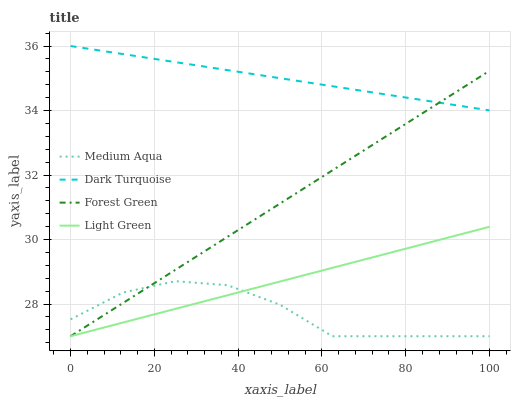Does Medium Aqua have the minimum area under the curve?
Answer yes or no. Yes. Does Dark Turquoise have the maximum area under the curve?
Answer yes or no. Yes. Does Forest Green have the minimum area under the curve?
Answer yes or no. No. Does Forest Green have the maximum area under the curve?
Answer yes or no. No. Is Forest Green the smoothest?
Answer yes or no. Yes. Is Medium Aqua the roughest?
Answer yes or no. Yes. Is Medium Aqua the smoothest?
Answer yes or no. No. Is Forest Green the roughest?
Answer yes or no. No. Does Forest Green have the lowest value?
Answer yes or no. Yes. Does Dark Turquoise have the highest value?
Answer yes or no. Yes. Does Forest Green have the highest value?
Answer yes or no. No. Is Light Green less than Dark Turquoise?
Answer yes or no. Yes. Is Dark Turquoise greater than Light Green?
Answer yes or no. Yes. Does Forest Green intersect Light Green?
Answer yes or no. Yes. Is Forest Green less than Light Green?
Answer yes or no. No. Is Forest Green greater than Light Green?
Answer yes or no. No. Does Light Green intersect Dark Turquoise?
Answer yes or no. No. 